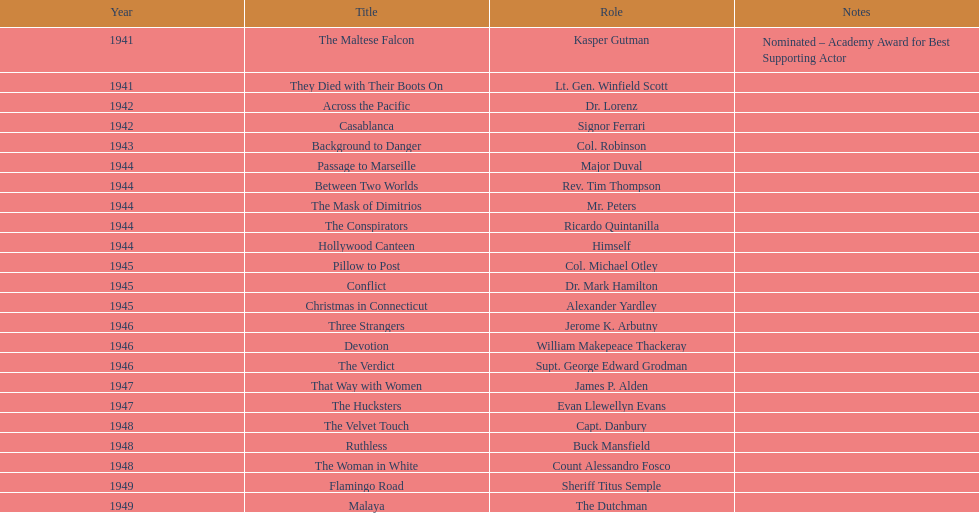How long did sydney greenstreet's acting career last? 9 years. 